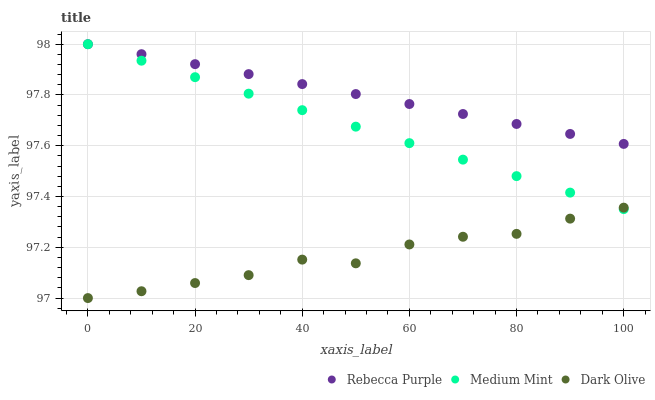Does Dark Olive have the minimum area under the curve?
Answer yes or no. Yes. Does Rebecca Purple have the maximum area under the curve?
Answer yes or no. Yes. Does Rebecca Purple have the minimum area under the curve?
Answer yes or no. No. Does Dark Olive have the maximum area under the curve?
Answer yes or no. No. Is Rebecca Purple the smoothest?
Answer yes or no. Yes. Is Dark Olive the roughest?
Answer yes or no. Yes. Is Dark Olive the smoothest?
Answer yes or no. No. Is Rebecca Purple the roughest?
Answer yes or no. No. Does Dark Olive have the lowest value?
Answer yes or no. Yes. Does Rebecca Purple have the lowest value?
Answer yes or no. No. Does Rebecca Purple have the highest value?
Answer yes or no. Yes. Does Dark Olive have the highest value?
Answer yes or no. No. Is Dark Olive less than Rebecca Purple?
Answer yes or no. Yes. Is Rebecca Purple greater than Dark Olive?
Answer yes or no. Yes. Does Medium Mint intersect Rebecca Purple?
Answer yes or no. Yes. Is Medium Mint less than Rebecca Purple?
Answer yes or no. No. Is Medium Mint greater than Rebecca Purple?
Answer yes or no. No. Does Dark Olive intersect Rebecca Purple?
Answer yes or no. No. 